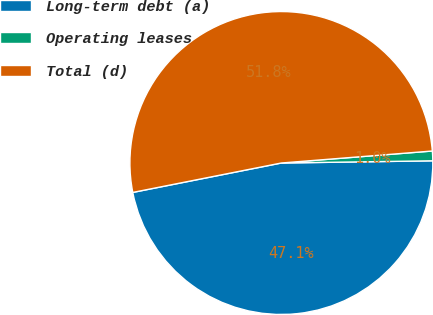Convert chart. <chart><loc_0><loc_0><loc_500><loc_500><pie_chart><fcel>Long-term debt (a)<fcel>Operating leases<fcel>Total (d)<nl><fcel>47.12%<fcel>1.03%<fcel>51.85%<nl></chart> 